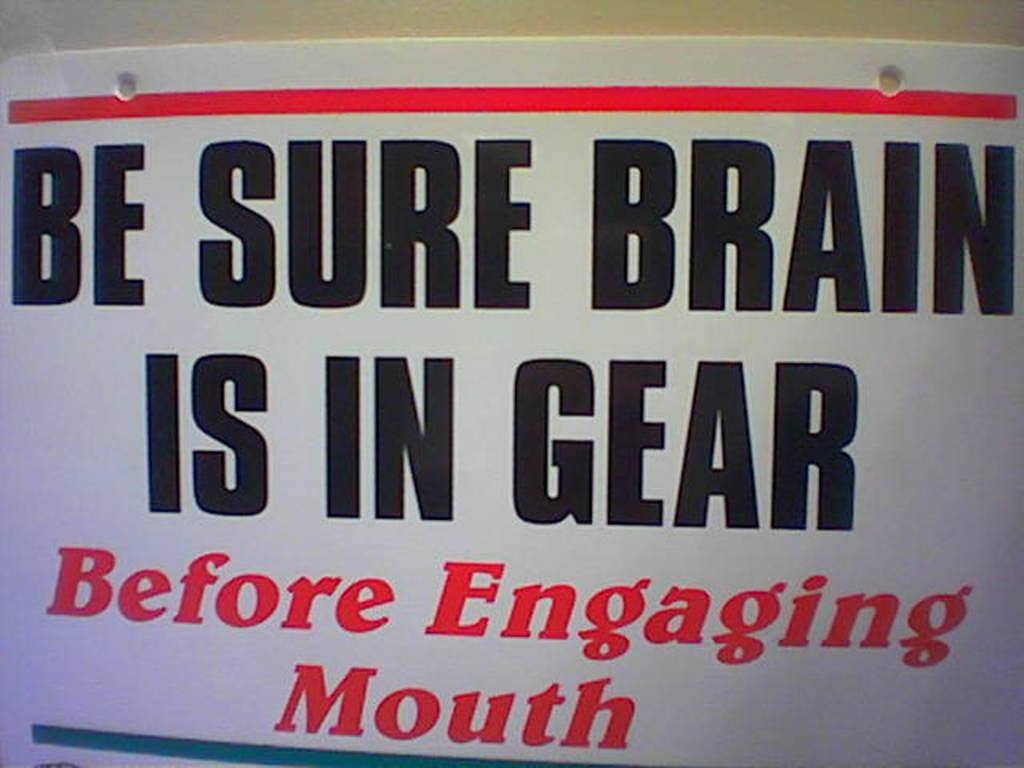<image>
Offer a succinct explanation of the picture presented. a poster that reads be sure brain is in gear 